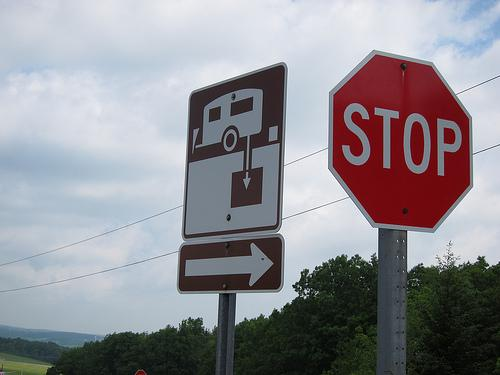Question: where do the signs tell trailers to go to dump waste?
Choices:
A. Left.
B. Right.
C. To the back.
D. To the front.
Answer with the letter. Answer: B Question: what color is the stop sign?
Choices:
A. Red.
B. Yellow.
C. Black.
D. Blue.
Answer with the letter. Answer: A Question: what color is the directing sign?
Choices:
A. Brown.
B. Yellow.
C. Red.
D. Orange.
Answer with the letter. Answer: A Question: who would be in this place?
Choices:
A. Campers.
B. Tourists.
C. Travelers.
D. Hikers.
Answer with the letter. Answer: A Question: what does the red sign say?
Choices:
A. Hault.
B. Slow down.
C. Stop.
D. No breaking.
Answer with the letter. Answer: C Question: where would the brown sign be used?
Choices:
A. Forest preserve.
B. Poolside.
C. Beach.
D. Trailer park.
Answer with the letter. Answer: D Question: how many people are in the picture?
Choices:
A. Seven.
B. Three.
C. None.
D. One.
Answer with the letter. Answer: C 